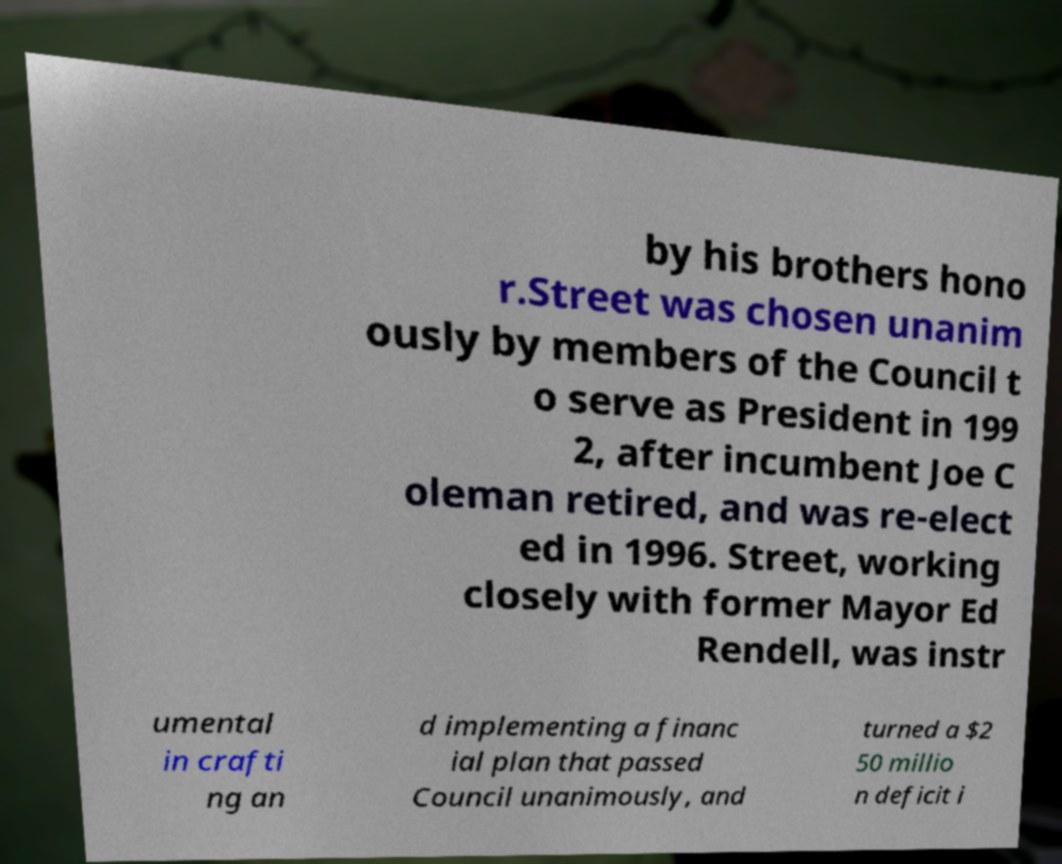What messages or text are displayed in this image? I need them in a readable, typed format. by his brothers hono r.Street was chosen unanim ously by members of the Council t o serve as President in 199 2, after incumbent Joe C oleman retired, and was re-elect ed in 1996. Street, working closely with former Mayor Ed Rendell, was instr umental in crafti ng an d implementing a financ ial plan that passed Council unanimously, and turned a $2 50 millio n deficit i 